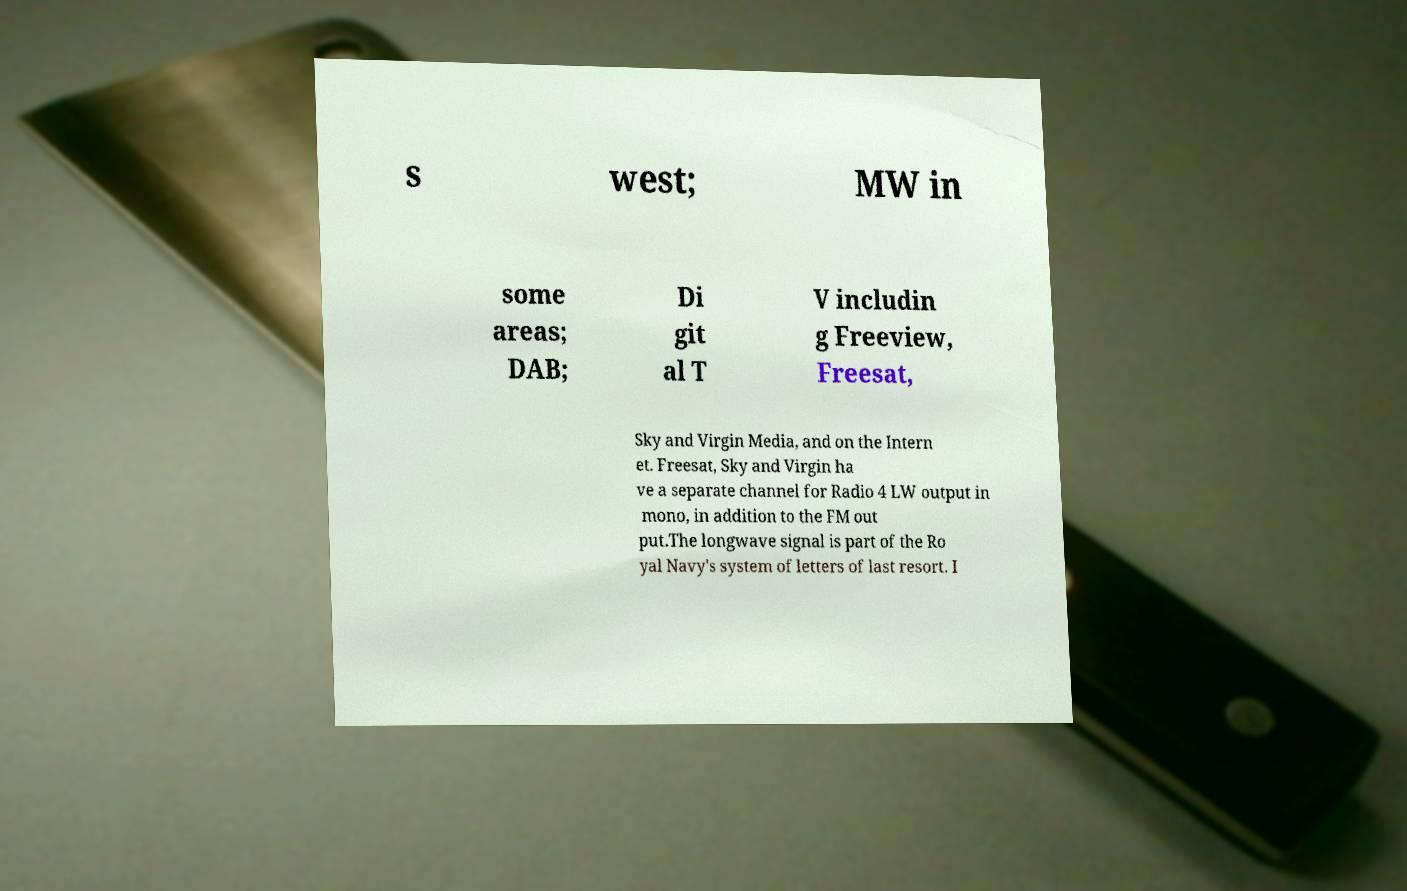Could you assist in decoding the text presented in this image and type it out clearly? s west; MW in some areas; DAB; Di git al T V includin g Freeview, Freesat, Sky and Virgin Media, and on the Intern et. Freesat, Sky and Virgin ha ve a separate channel for Radio 4 LW output in mono, in addition to the FM out put.The longwave signal is part of the Ro yal Navy's system of letters of last resort. I 